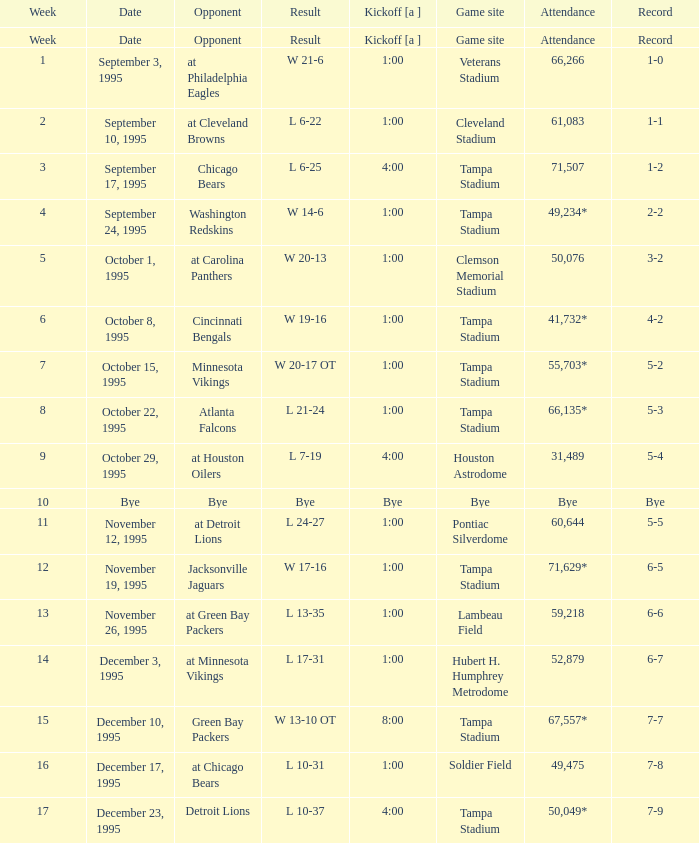On what date was Tampa Bay's Week 4 game? September 24, 1995. 